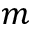<formula> <loc_0><loc_0><loc_500><loc_500>m</formula> 